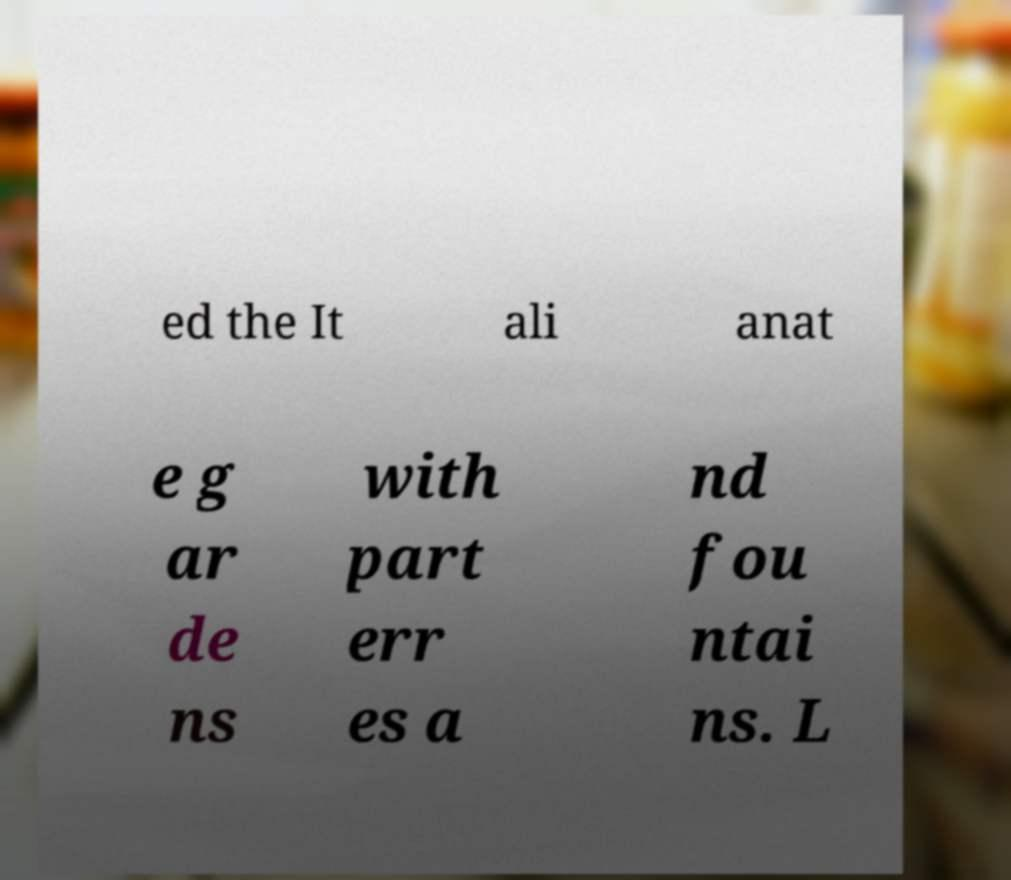Could you assist in decoding the text presented in this image and type it out clearly? ed the It ali anat e g ar de ns with part err es a nd fou ntai ns. L 